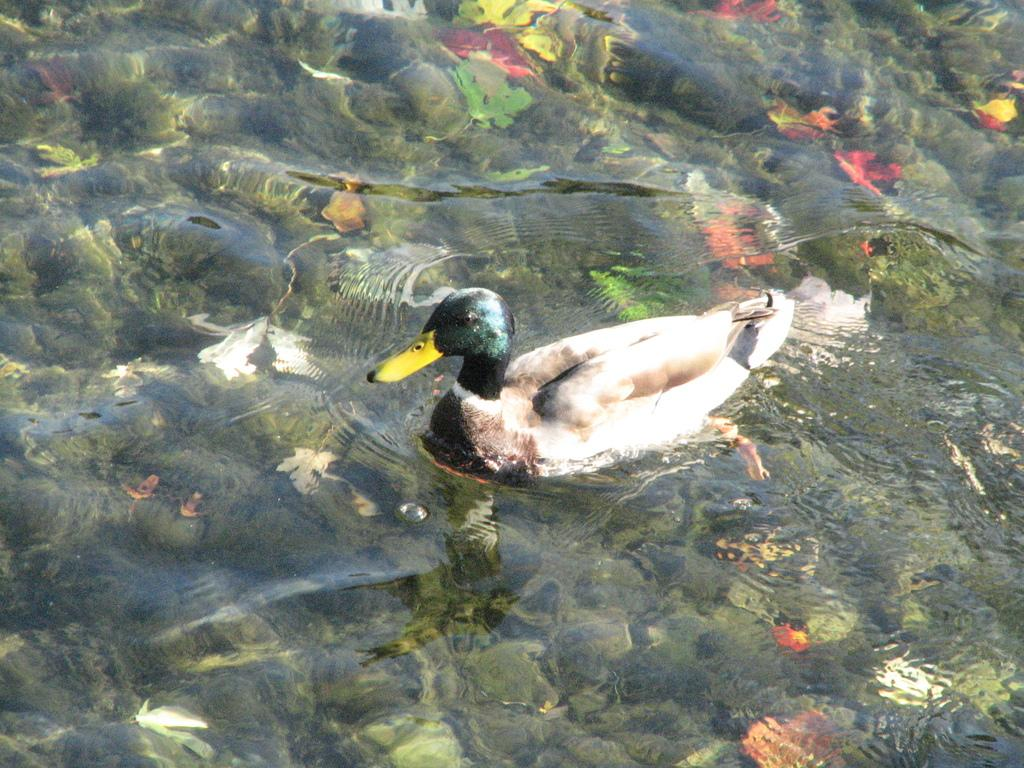What animal is present in the image? There is a duck in the image. What is the duck doing in the image? The duck is swimming in the water. What thought is the duck having while swimming in the image? There is no way to determine the duck's thoughts from the image, as animals do not express thoughts in the same way as humans. 